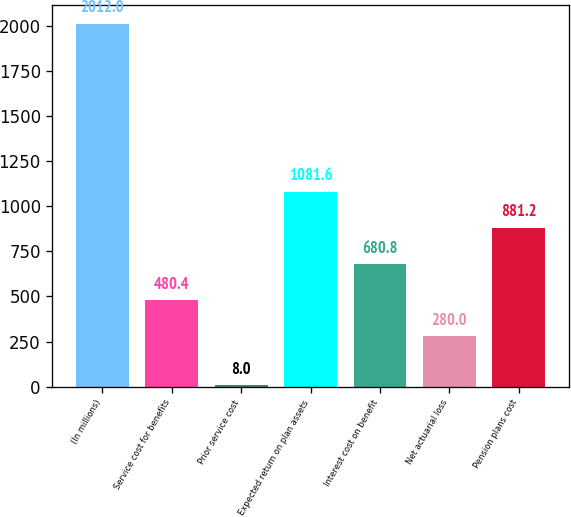Convert chart. <chart><loc_0><loc_0><loc_500><loc_500><bar_chart><fcel>(In millions)<fcel>Service cost for benefits<fcel>Prior service cost<fcel>Expected return on plan assets<fcel>Interest cost on benefit<fcel>Net actuarial loss<fcel>Pension plans cost<nl><fcel>2012<fcel>480.4<fcel>8<fcel>1081.6<fcel>680.8<fcel>280<fcel>881.2<nl></chart> 